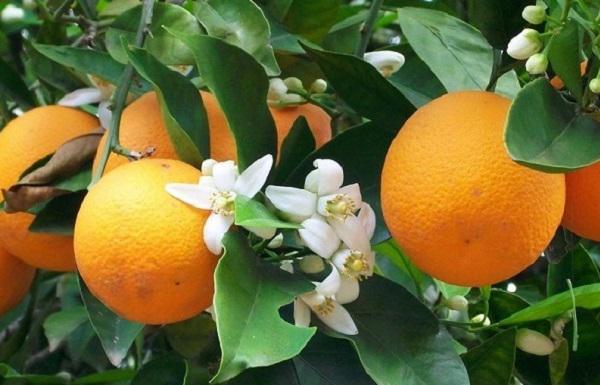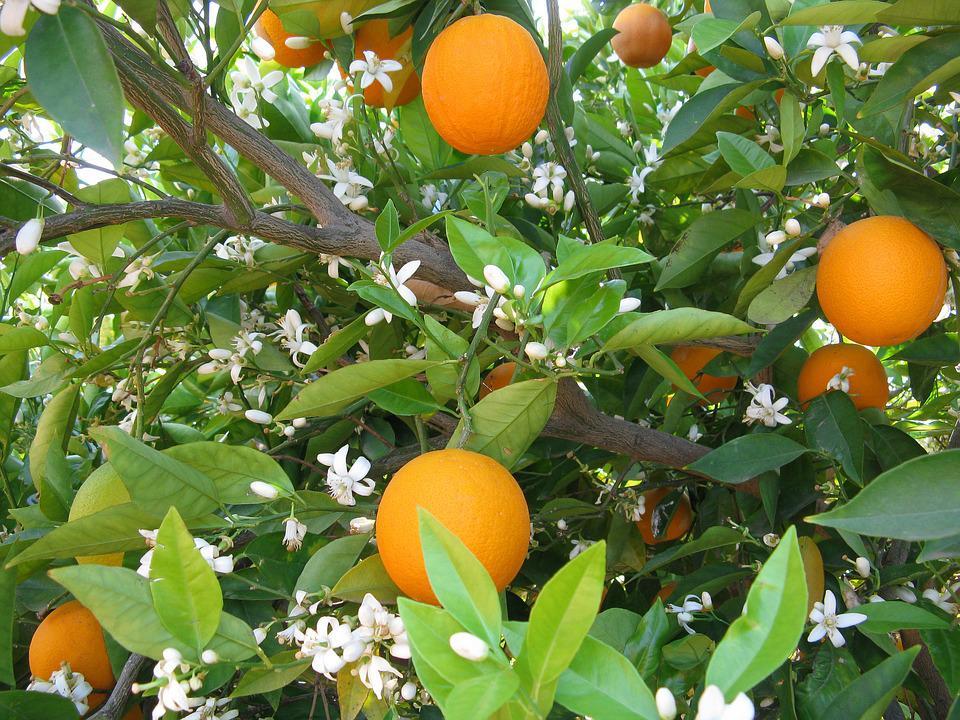The first image is the image on the left, the second image is the image on the right. Assess this claim about the two images: "None of the orange trees have bloomed.". Correct or not? Answer yes or no. No. 